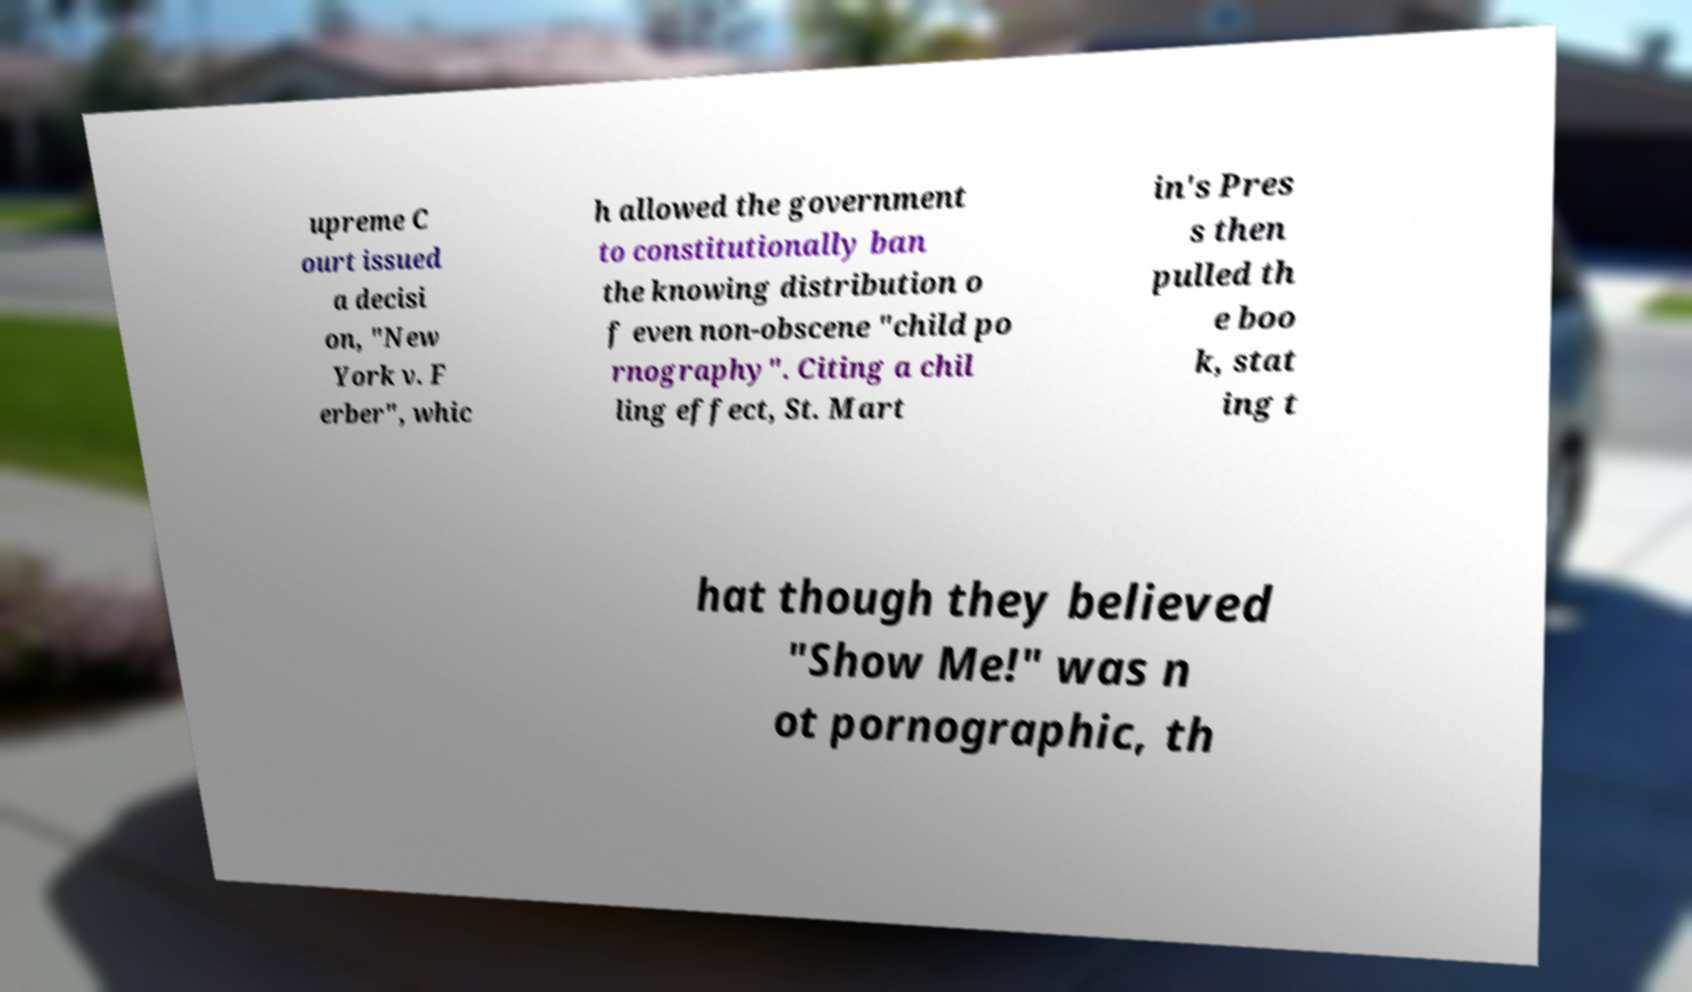Could you extract and type out the text from this image? upreme C ourt issued a decisi on, "New York v. F erber", whic h allowed the government to constitutionally ban the knowing distribution o f even non-obscene "child po rnography". Citing a chil ling effect, St. Mart in's Pres s then pulled th e boo k, stat ing t hat though they believed "Show Me!" was n ot pornographic, th 